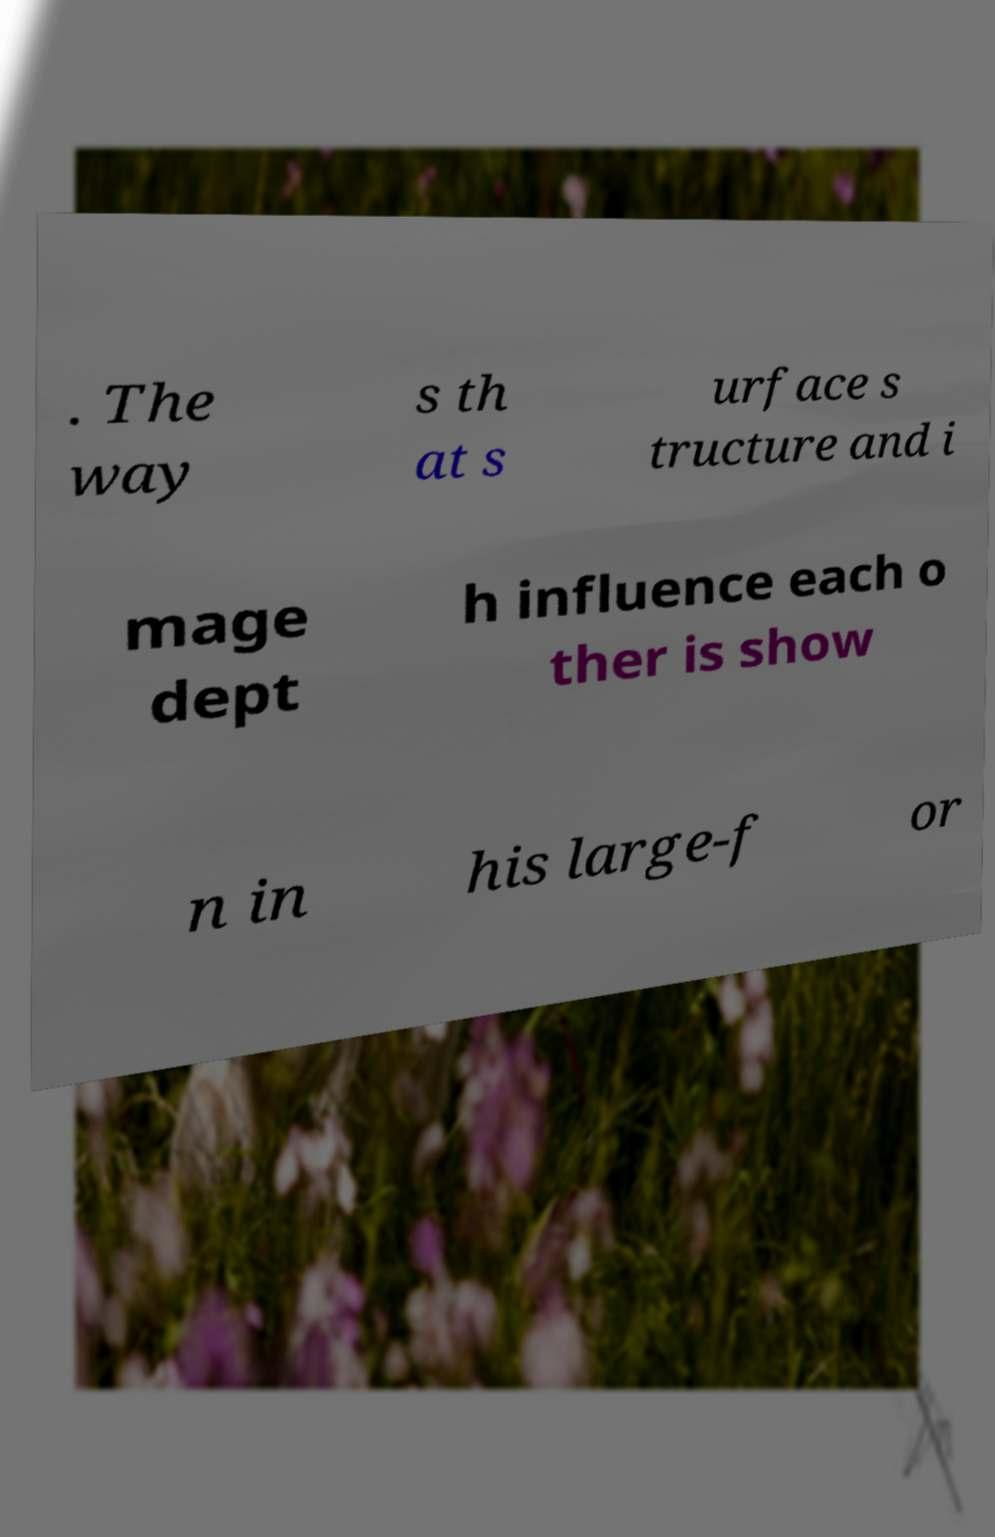For documentation purposes, I need the text within this image transcribed. Could you provide that? . The way s th at s urface s tructure and i mage dept h influence each o ther is show n in his large-f or 